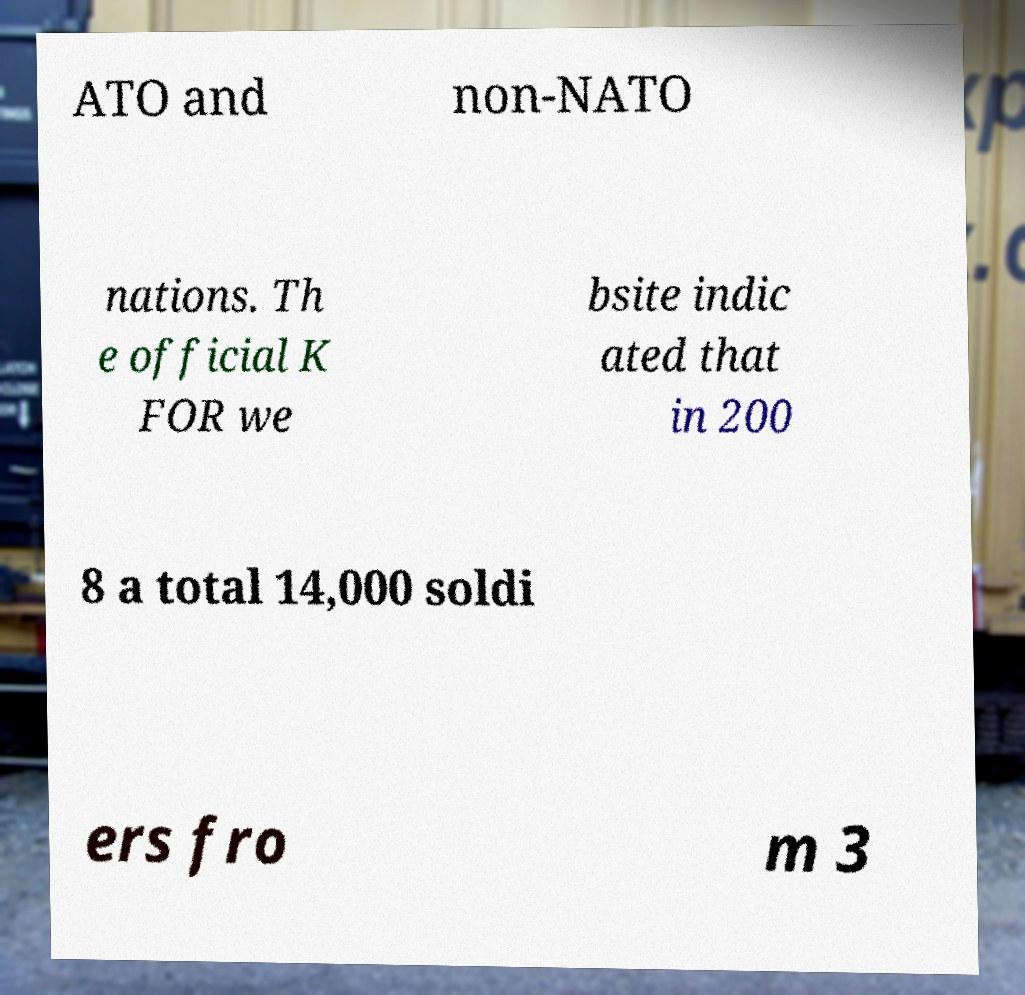I need the written content from this picture converted into text. Can you do that? ATO and non-NATO nations. Th e official K FOR we bsite indic ated that in 200 8 a total 14,000 soldi ers fro m 3 